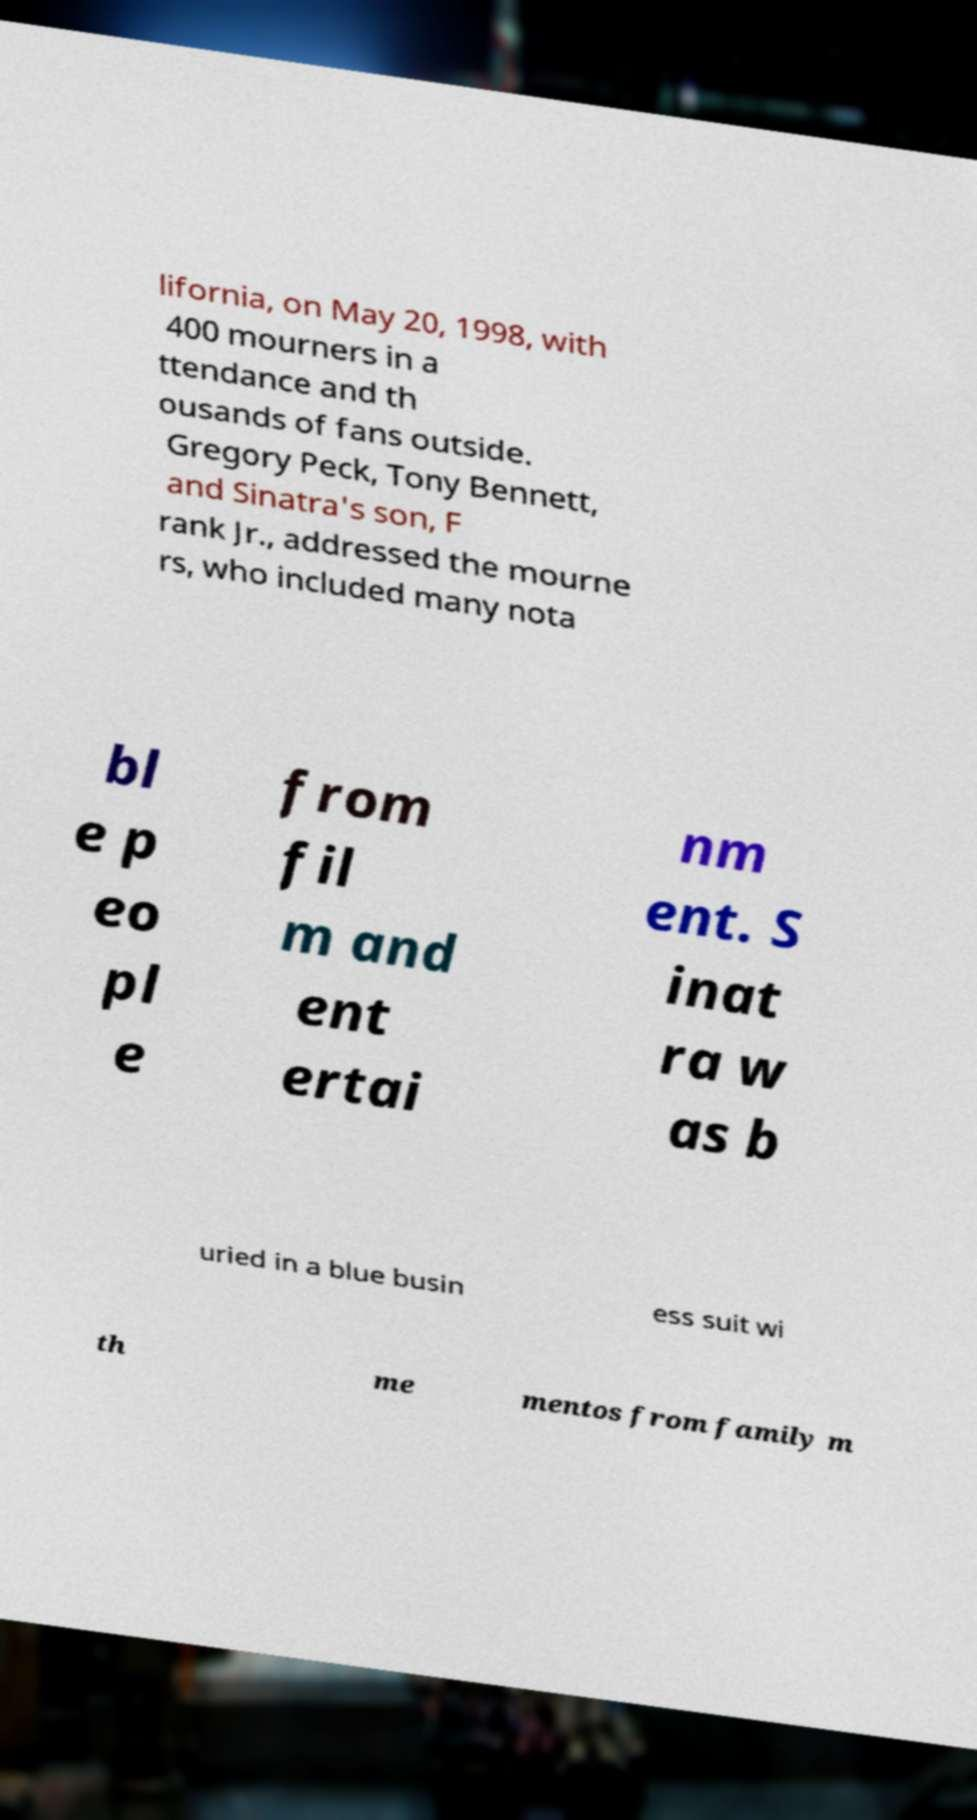Please read and relay the text visible in this image. What does it say? lifornia, on May 20, 1998, with 400 mourners in a ttendance and th ousands of fans outside. Gregory Peck, Tony Bennett, and Sinatra's son, F rank Jr., addressed the mourne rs, who included many nota bl e p eo pl e from fil m and ent ertai nm ent. S inat ra w as b uried in a blue busin ess suit wi th me mentos from family m 